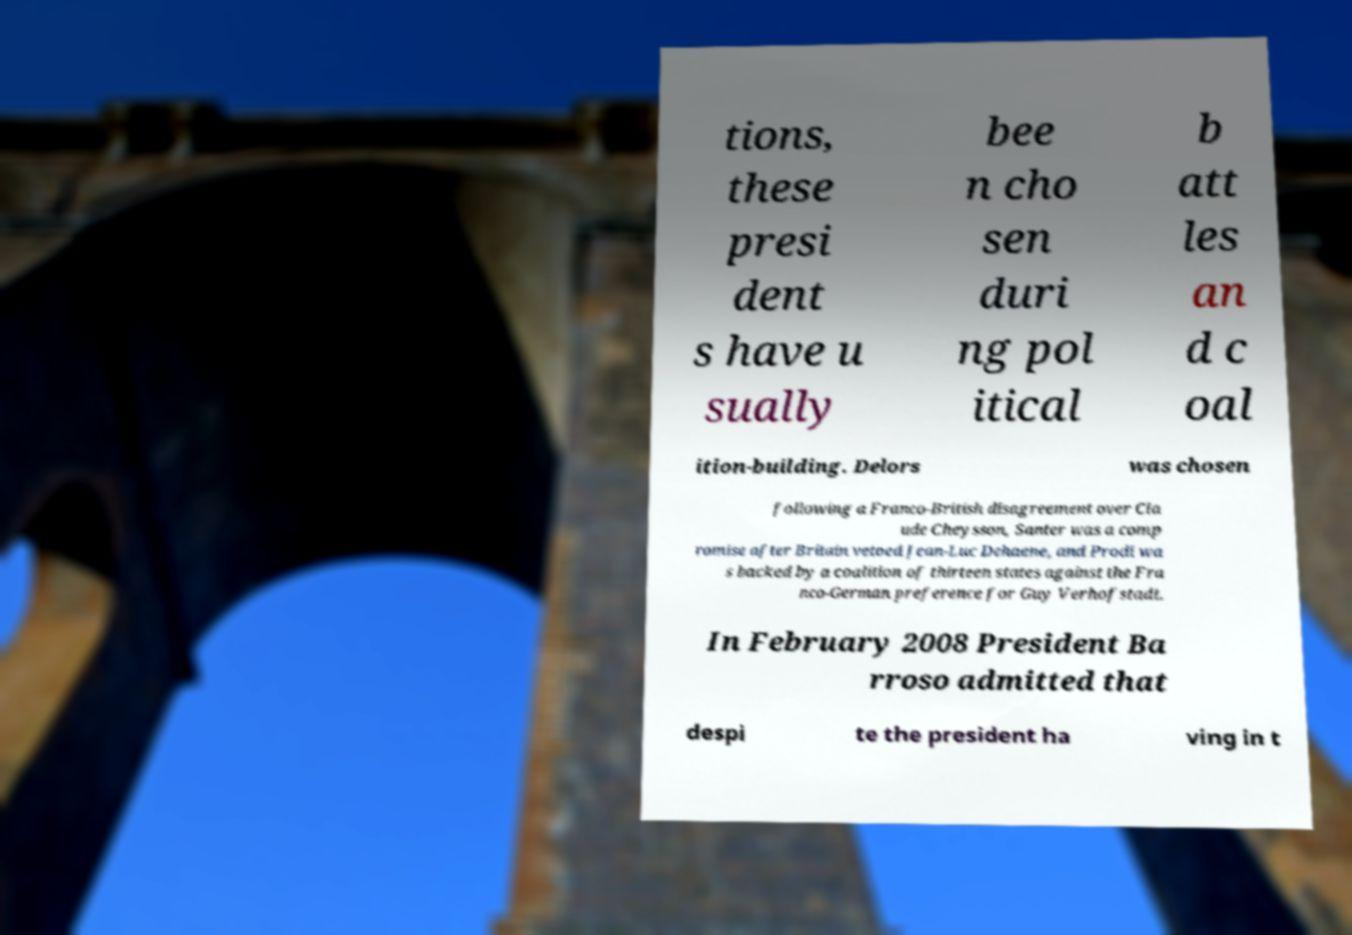Could you extract and type out the text from this image? tions, these presi dent s have u sually bee n cho sen duri ng pol itical b att les an d c oal ition-building. Delors was chosen following a Franco-British disagreement over Cla ude Cheysson, Santer was a comp romise after Britain vetoed Jean-Luc Dehaene, and Prodi wa s backed by a coalition of thirteen states against the Fra nco-German preference for Guy Verhofstadt. In February 2008 President Ba rroso admitted that despi te the president ha ving in t 